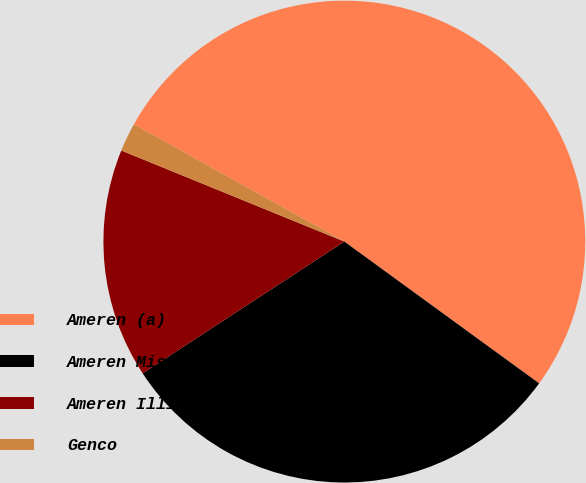Convert chart to OTSL. <chart><loc_0><loc_0><loc_500><loc_500><pie_chart><fcel>Ameren (a)<fcel>Ameren Missouri<fcel>Ameren Illinois<fcel>Genco<nl><fcel>51.92%<fcel>30.77%<fcel>15.38%<fcel>1.92%<nl></chart> 